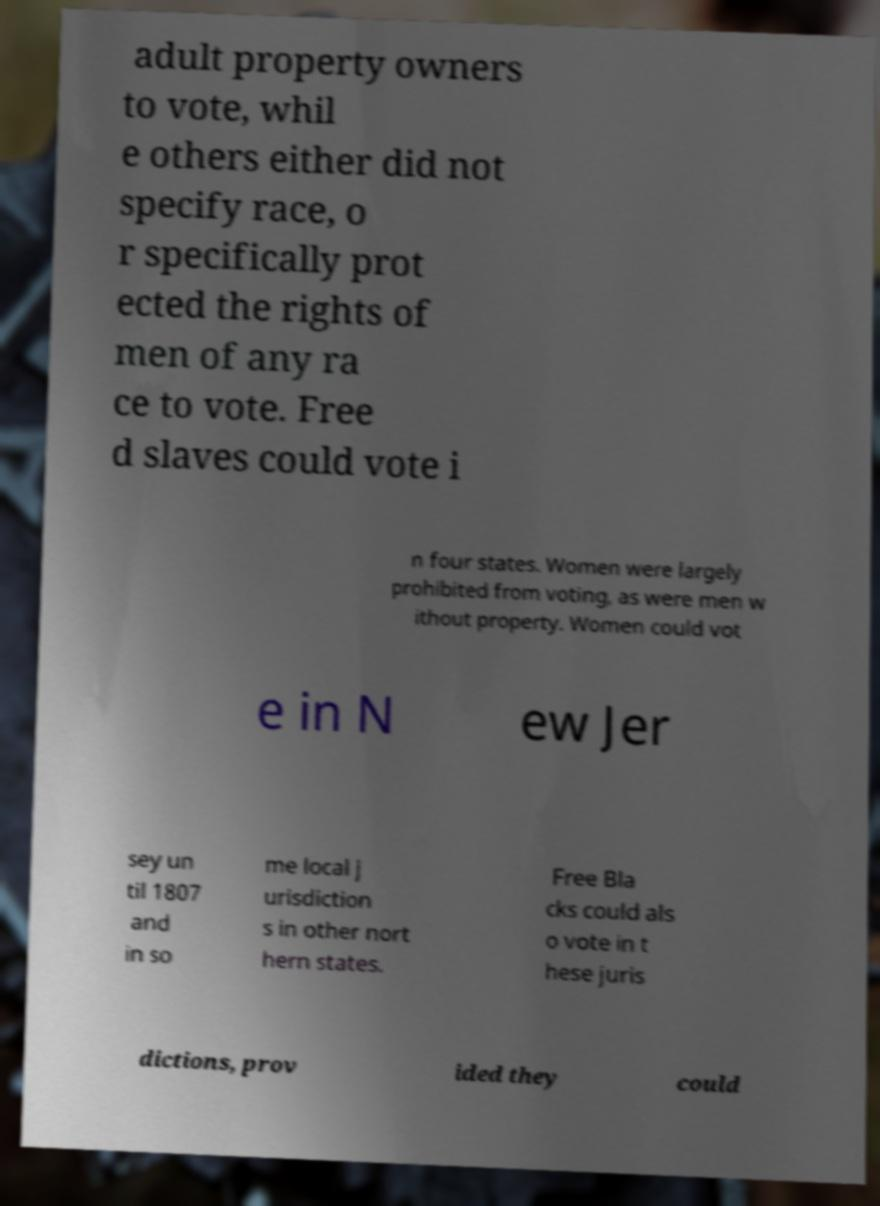For documentation purposes, I need the text within this image transcribed. Could you provide that? adult property owners to vote, whil e others either did not specify race, o r specifically prot ected the rights of men of any ra ce to vote. Free d slaves could vote i n four states. Women were largely prohibited from voting, as were men w ithout property. Women could vot e in N ew Jer sey un til 1807 and in so me local j urisdiction s in other nort hern states. Free Bla cks could als o vote in t hese juris dictions, prov ided they could 